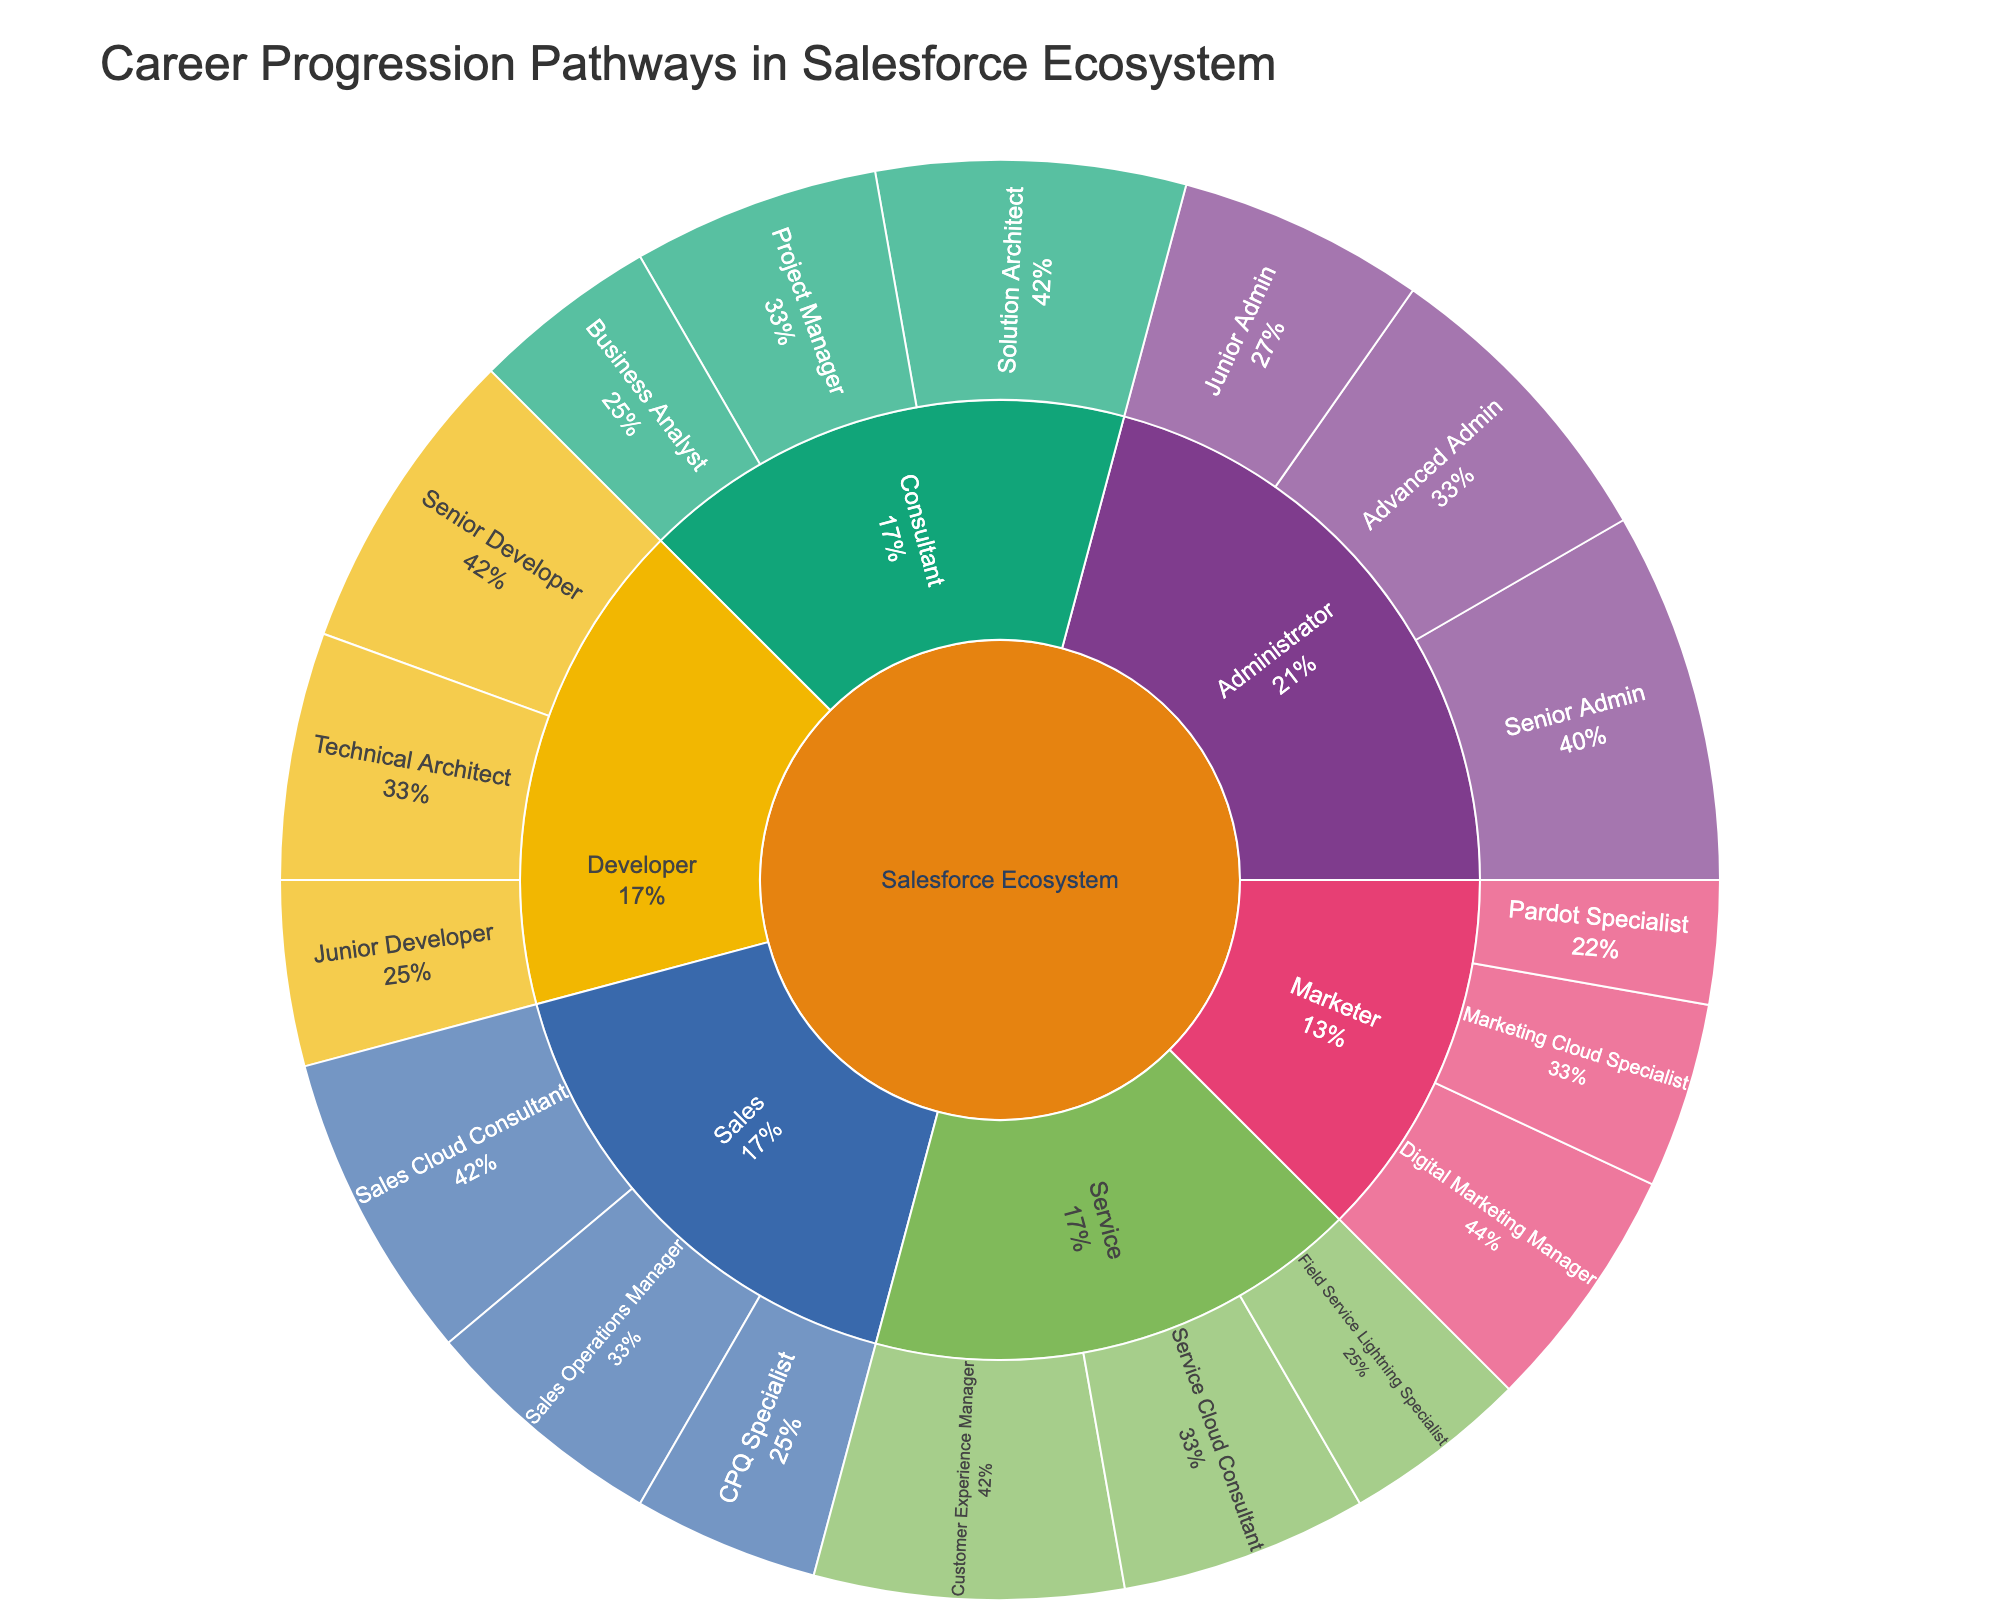What is the title of the figure? The title is usually found at the top of the figure. In this case, the title of the Sunburst Plot is "Career Progression Pathways in Salesforce Ecosystem".
Answer: Career Progression Pathways in Salesforce Ecosystem How many subcategories are there under the "Developer" category? Look at the Developer branch of the Sunburst Plot and count the number of subcategories (inner ring sections branching from Developer). The subcategories are Junior Developer, Senior Developer, and Technical Architect.
Answer: 3 Which category has the lowest total value in the plot? To determine this, sum the values of the subcategories within each category. Compare the sums: Administrator (75), Developer (60), Consultant (60), Marketer (45), Sales (60), Service (60). Marketer has the lowest total value.
Answer: Marketer What is the percentage of "Junior Admin" within the "Administrator" category? Find the value of the Junior Admin (20) and divide it by the total value for Administrator (75). Then multiply by 100 to get the percentage: (20/75)*100 = 26.7%.
Answer: 26.7% Compare the total number of opportunities between "Sales" and "Service" categories. Which has more? Sum the values of the subcategories within Sales (25 + 15 + 20 = 60) and Service (20 + 15 + 25 = 60). Both categories have the same total value.
Answer: Equal Which specialization has the highest number of opportunities? Look for the subcategory with the highest value in the plot. The Customer Experience Manager in the Service category has the highest value at 25.
Answer: Customer Experience Manager How does the number of "Technical Architects" compare to "Solution Architects"? Compare the values for Technical Architect (20) and Solution Architect (25).
Answer: Solution Architect has more If you combine the total values of the "Junior Developer" and "Senior Developer" roles, does it equal the total value of the "Sales Cloud Consultant" role? Sum the values of Junior Developer and Senior Developer (15 + 25 = 40) and compare with Sales Cloud Consultant (25).
Answer: No What percentage of "Marketer" roles does the "Digital Marketing Manager" account for? Find the value of Digital Marketing Manager (20) and the total for Marketer (45). Calculate the percentage: (20/45)*100 ≈ 44.4%.
Answer: 44.4% How does the combined total of "Administrator" roles compare to the combined total of "Consultant" roles in terms of opportunities? Sum the values for Administrator (75) and Consultant (60) and compare them. Administrator has a higher total.
Answer: Administrator has more 